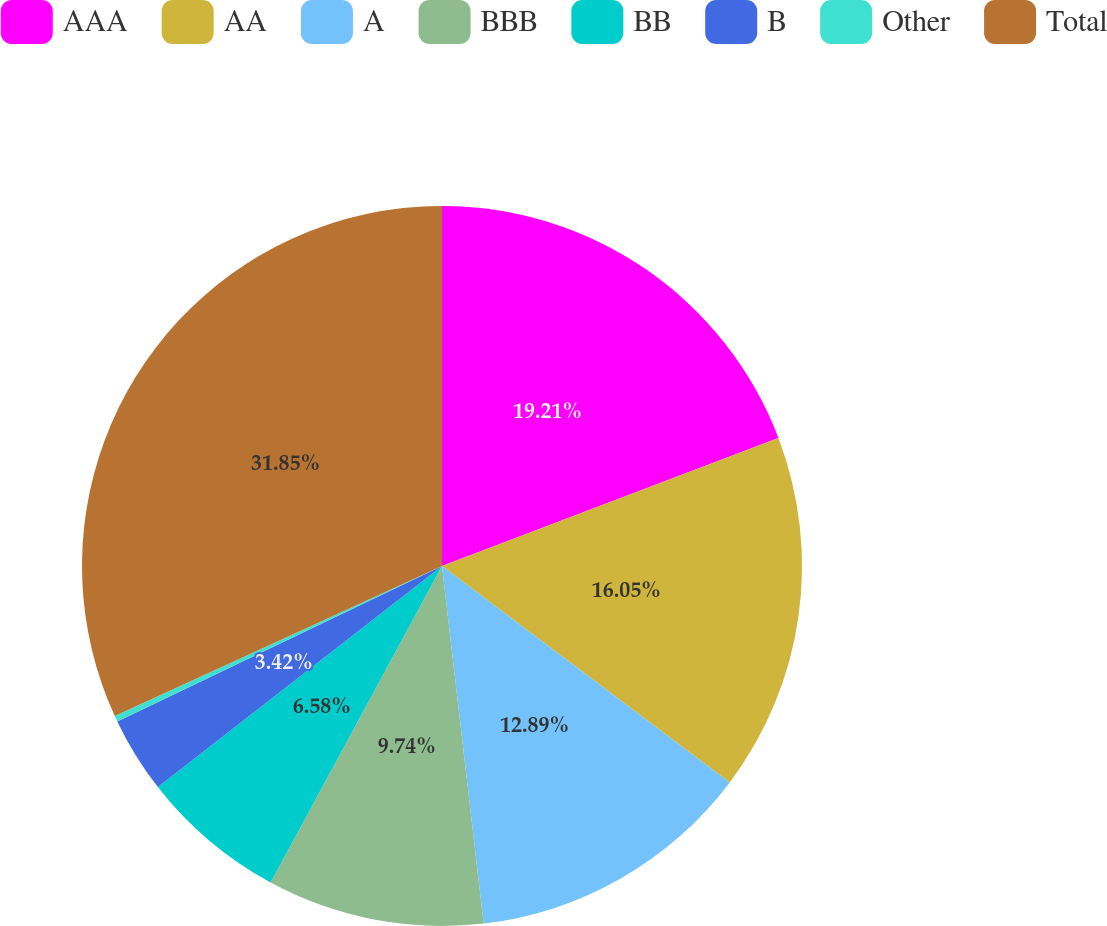Convert chart to OTSL. <chart><loc_0><loc_0><loc_500><loc_500><pie_chart><fcel>AAA<fcel>AA<fcel>A<fcel>BBB<fcel>BB<fcel>B<fcel>Other<fcel>Total<nl><fcel>19.21%<fcel>16.05%<fcel>12.89%<fcel>9.74%<fcel>6.58%<fcel>3.42%<fcel>0.26%<fcel>31.84%<nl></chart> 